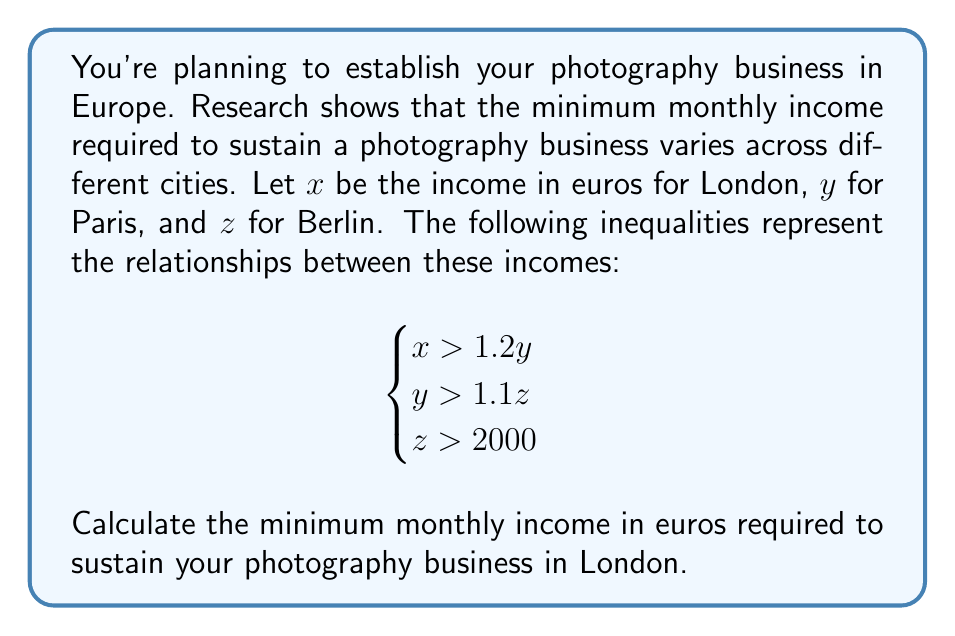Could you help me with this problem? Let's solve this step-by-step:

1) We start with the given system of inequalities:
   $$\begin{cases}
   x > 1.2y \\
   y > 1.1z \\
   z > 2000
   \end{cases}$$

2) From the third inequality, we know that $z > 2000$. To find the minimum possible value for $z$, we can say:
   $z = 2000 + \varepsilon$, where $\varepsilon$ is an infinitesimally small positive number.

3) Now, let's substitute this into the second inequality:
   $y > 1.1z = 1.1(2000 + \varepsilon) = 2200 + 1.1\varepsilon$

4) To find the minimum value for $y$, we can say:
   $y = 2200 + 1.1\varepsilon + \delta$, where $\delta$ is another infinitesimally small positive number.

5) Finally, let's substitute this into the first inequality:
   $x > 1.2y = 1.2(2200 + 1.1\varepsilon + \delta) = 2640 + 1.32\varepsilon + 1.2\delta$

6) Therefore, the minimum value for $x$ is:
   $x = 2640 + 1.32\varepsilon + 1.2\delta + \gamma$, where $\gamma$ is a third infinitesimally small positive number.

7) As $\varepsilon$, $\delta$, and $\gamma$ are infinitesimally small, we can effectively ignore them when considering the practical minimum income.

Thus, the minimum monthly income required for London is 2640 euros.
Answer: 2640 euros 